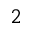Convert formula to latex. <formula><loc_0><loc_0><loc_500><loc_500>_ { 2 }</formula> 